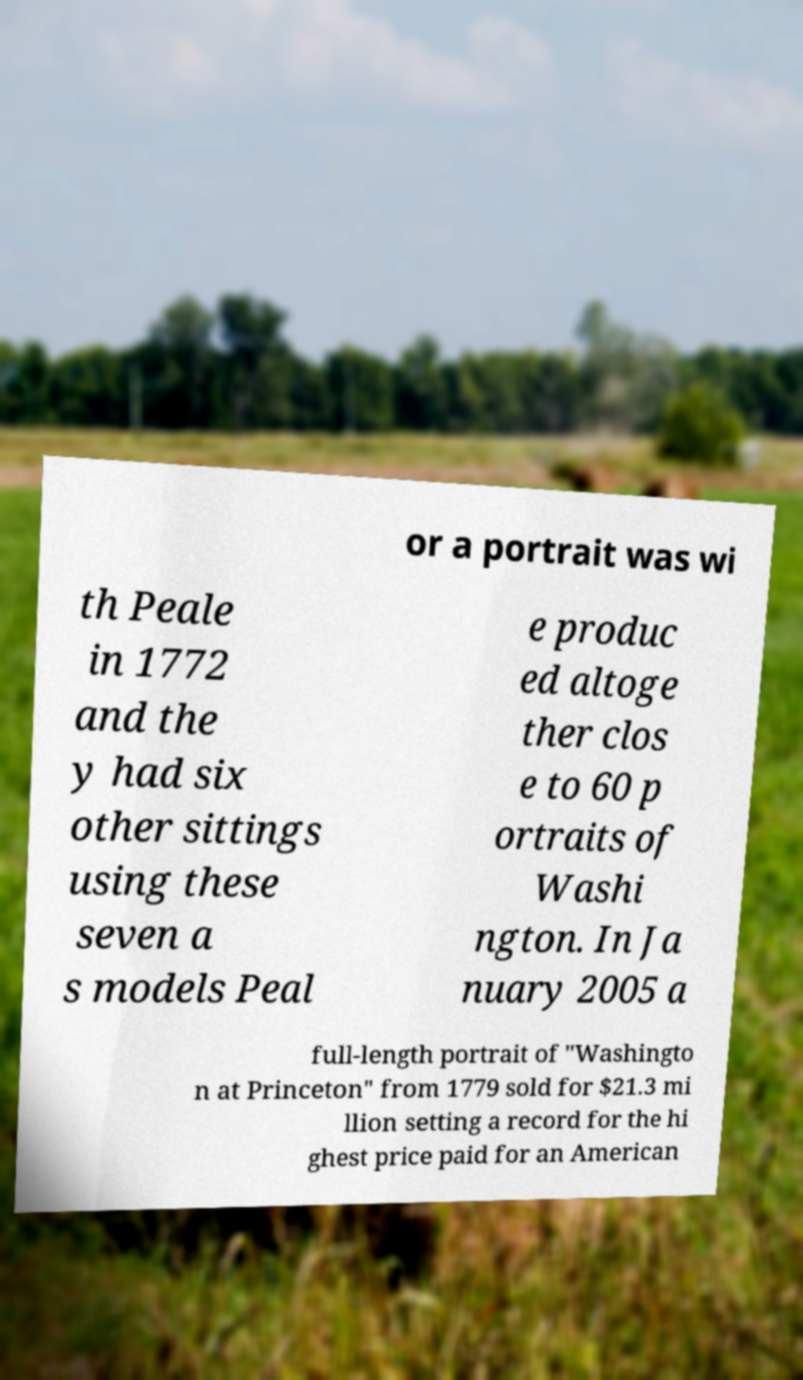Could you assist in decoding the text presented in this image and type it out clearly? or a portrait was wi th Peale in 1772 and the y had six other sittings using these seven a s models Peal e produc ed altoge ther clos e to 60 p ortraits of Washi ngton. In Ja nuary 2005 a full-length portrait of "Washingto n at Princeton" from 1779 sold for $21.3 mi llion setting a record for the hi ghest price paid for an American 